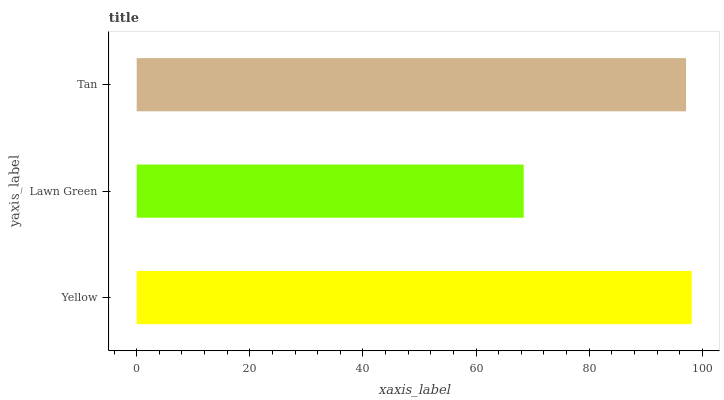Is Lawn Green the minimum?
Answer yes or no. Yes. Is Yellow the maximum?
Answer yes or no. Yes. Is Tan the minimum?
Answer yes or no. No. Is Tan the maximum?
Answer yes or no. No. Is Tan greater than Lawn Green?
Answer yes or no. Yes. Is Lawn Green less than Tan?
Answer yes or no. Yes. Is Lawn Green greater than Tan?
Answer yes or no. No. Is Tan less than Lawn Green?
Answer yes or no. No. Is Tan the high median?
Answer yes or no. Yes. Is Tan the low median?
Answer yes or no. Yes. Is Lawn Green the high median?
Answer yes or no. No. Is Yellow the low median?
Answer yes or no. No. 